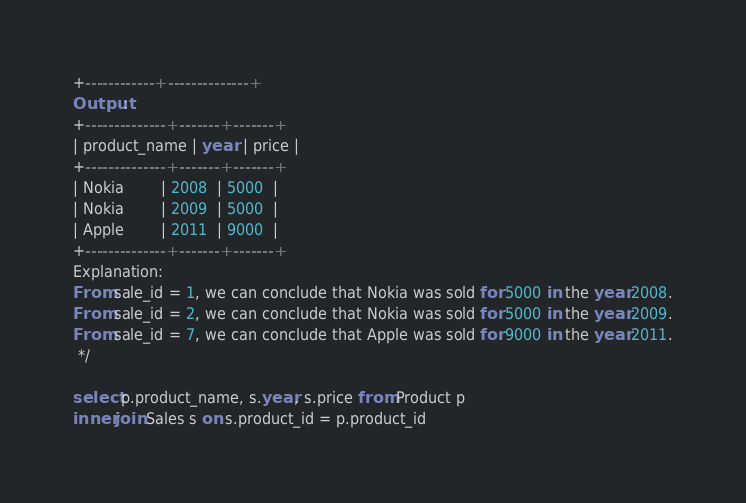<code> <loc_0><loc_0><loc_500><loc_500><_SQL_>+------------+--------------+
Output:
+--------------+-------+-------+
| product_name | year  | price |
+--------------+-------+-------+
| Nokia        | 2008  | 5000  |
| Nokia        | 2009  | 5000  |
| Apple        | 2011  | 9000  |
+--------------+-------+-------+
Explanation:
From sale_id = 1, we can conclude that Nokia was sold for 5000 in the year 2008.
From sale_id = 2, we can conclude that Nokia was sold for 5000 in the year 2009.
From sale_id = 7, we can conclude that Apple was sold for 9000 in the year 2011.
 */

select p.product_name, s.year, s.price from Product p
inner join Sales s on s.product_id = p.product_id</code> 